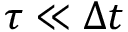<formula> <loc_0><loc_0><loc_500><loc_500>\tau \ll \Delta t</formula> 